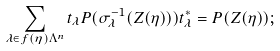<formula> <loc_0><loc_0><loc_500><loc_500>\sum _ { \lambda \in f ( \eta ) \Lambda ^ { n } } t _ { \lambda } P ( \sigma _ { \lambda } ^ { - 1 } ( Z ( \eta ) ) ) t _ { \lambda } ^ { * } = P ( Z ( \eta ) ) ;</formula> 